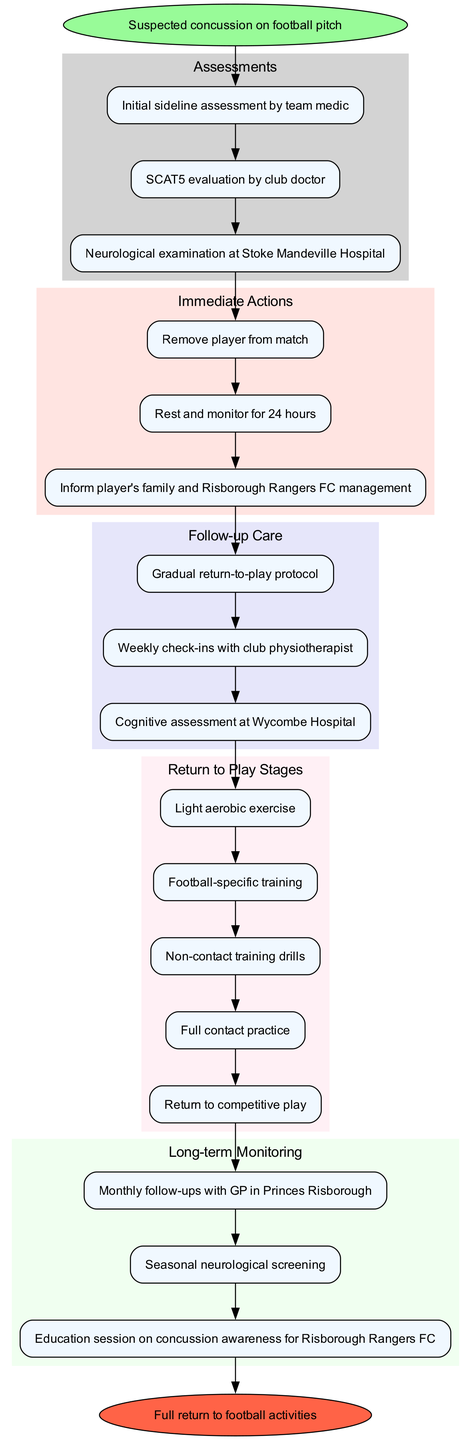What is the first step in the pathway? The first step is the "Suspected concussion on football pitch." This is the starting point of the pathway and initiates the flow toward assessments.
Answer: Suspected concussion on football pitch How many assessments are conducted? There are three assessments listed in the pathway: Initial sideline assessment by team medic, SCAT5 evaluation by club doctor, and Neurological examination at Stoke Mandeville Hospital. These are all essential evaluations before progressing to the immediate actions.
Answer: 3 What follows the immediate actions? The immediate action leads directly to the follow-up care. After actions such as removing the player and monitoring, the pathway continues to the steps of follow-up care to ensure proper recovery.
Answer: Follow-up care Which assessment comes last in the sequence? The last assessment in the sequence is the "Neurological examination at Stoke Mandeville Hospital," as it follows the other two assessments in order before any actions are taken.
Answer: Neurological examination at Stoke Mandeville Hospital What is the final goal of the clinical pathway? The end goal of the pathway is a "Full return to football activities." This indicates that the player has successfully completed all prior steps and is cleared to return to play.
Answer: Full return to football activities Which stage comes after light aerobic exercise in the return-to-play protocol? The stage that follows light aerobic exercise is "Football-specific training." This showcases the progression that a player must go through before returning to competitive play.
Answer: Football-specific training How many steps are included in the return to play stages? There are five stages included in the return-to-play protocol: Light aerobic exercise, Football-specific training, Non-contact training drills, Full contact practice, and Return to competitive play. This represents the gradual process designed for safe return.
Answer: 5 What type of follow-up care involves cognitive assessment? The follow-up care that involves cognitive assessment is "Cognitive assessment at Wycombe Hospital." This step ensures proper mental recovery alongside physical recovery after a concussion.
Answer: Cognitive assessment at Wycombe Hospital 